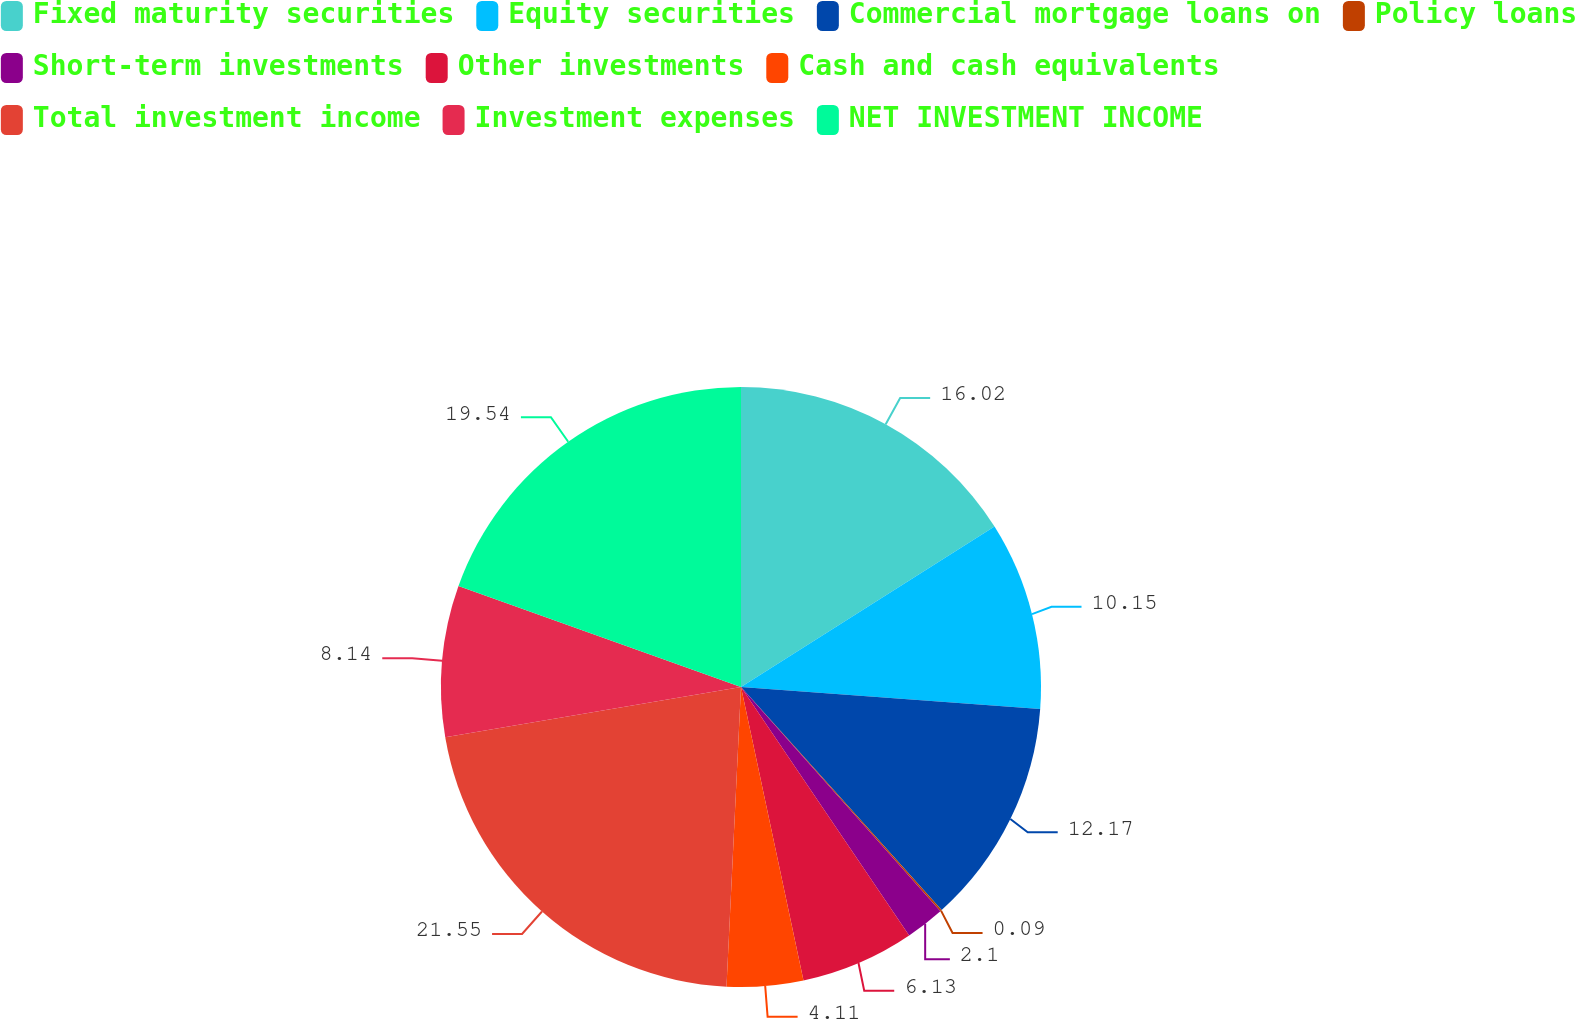Convert chart to OTSL. <chart><loc_0><loc_0><loc_500><loc_500><pie_chart><fcel>Fixed maturity securities<fcel>Equity securities<fcel>Commercial mortgage loans on<fcel>Policy loans<fcel>Short-term investments<fcel>Other investments<fcel>Cash and cash equivalents<fcel>Total investment income<fcel>Investment expenses<fcel>NET INVESTMENT INCOME<nl><fcel>16.02%<fcel>10.15%<fcel>12.17%<fcel>0.09%<fcel>2.1%<fcel>6.13%<fcel>4.11%<fcel>21.55%<fcel>8.14%<fcel>19.54%<nl></chart> 